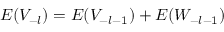<formula> <loc_0><loc_0><loc_500><loc_500>E ( V _ { - l } ) = E ( V _ { - l - 1 } ) + E ( W _ { - l - 1 } )</formula> 